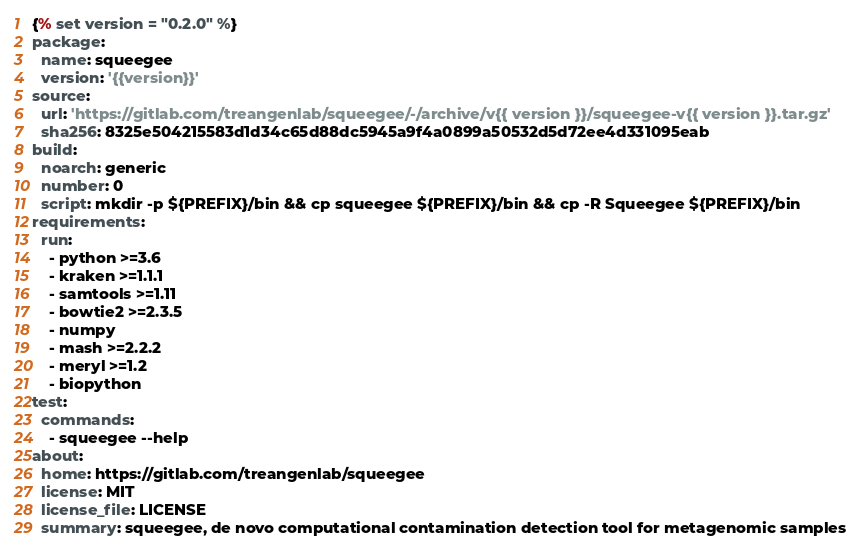<code> <loc_0><loc_0><loc_500><loc_500><_YAML_>{% set version = "0.2.0" %}
package:
  name: squeegee
  version: '{{version}}'
source:
  url: 'https://gitlab.com/treangenlab/squeegee/-/archive/v{{ version }}/squeegee-v{{ version }}.tar.gz'
  sha256: 8325e504215583d1d34c65d88dc5945a9f4a0899a50532d5d72ee4d331095eab 
build:
  noarch: generic
  number: 0
  script: mkdir -p ${PREFIX}/bin && cp squeegee ${PREFIX}/bin && cp -R Squeegee ${PREFIX}/bin
requirements:
  run:
    - python >=3.6
    - kraken >=1.1.1
    - samtools >=1.11
    - bowtie2 >=2.3.5
    - numpy
    - mash >=2.2.2
    - meryl >=1.2
    - biopython
test:
  commands:
    - squeegee --help
about:
  home: https://gitlab.com/treangenlab/squeegee
  license: MIT
  license_file: LICENSE
  summary: squeegee, de novo computational contamination detection tool for metagenomic samples
</code> 